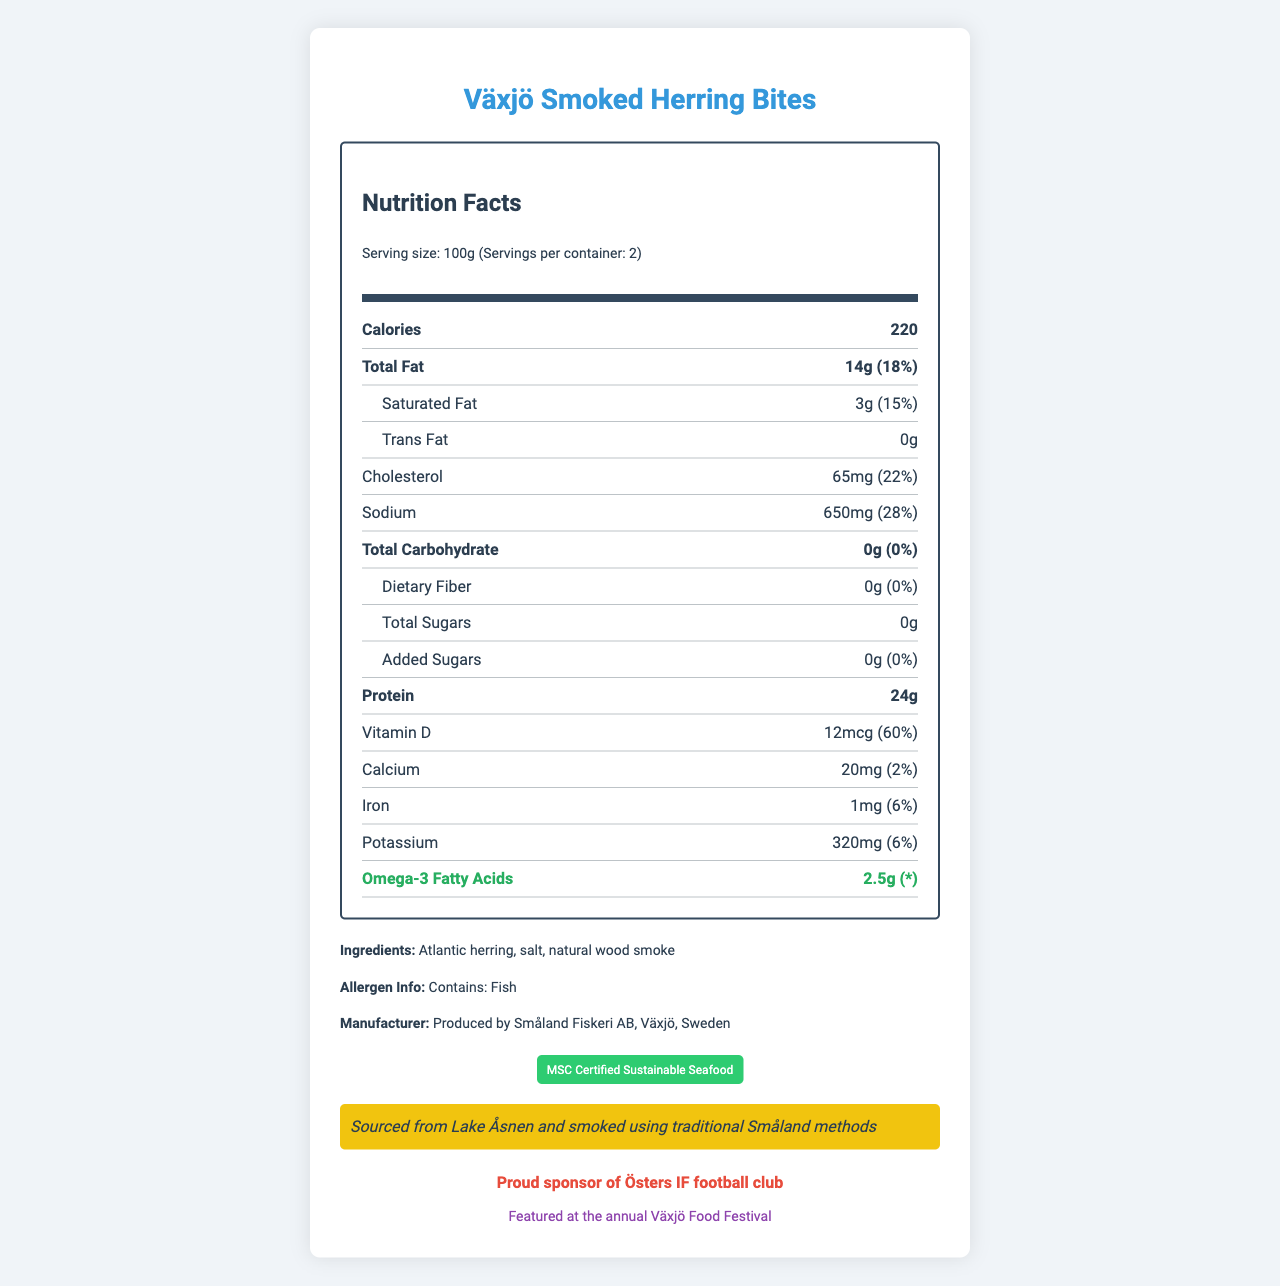how many servings are in the container? The document indicates that there are 2 servings per container.
Answer: 2 how many calories are in one serving? The label shows that each serving has 220 calories.
Answer: 220 what is the amount of omega-3 fatty acids in one serving? The document lists 2.5g of omega-3 fatty acids per serving.
Answer: 2.5g what company manufactures Växjö Smoked Herring Bites? The manufacturer is stated to be Småland Fiskeri AB, Växjö, Sweden.
Answer: Småland Fiskeri AB are these herring bites a good source of vitamin D? The document shows that one serving provides 60% of the daily value of vitamin D.
Answer: Yes how much sodium does one serving of Växjö Smoked Herring Bites contain? The label indicates that one serving contains 650mg of sodium.
Answer: 650mg which of the following is an ingredient in Växjö Smoked Herring Bites? I. Atlantic herring II. Tuna III. Salmon The ingredients list specifies Atlantic herring, salt, and natural wood smoke.
Answer: I. Atlantic herring what is the daily value percentage of total fat in one serving? A. 18% B. 15% C. 22% The total fat content for one serving is 14g, which corresponds to 18% of the daily value.
Answer: A. 18% which community event features Växjö Smoked Herring Bites? 1. Växjö Food Festival 2. Växjö Music Festival 3. Växjö Art Festival The document states that the Växjö Smoked Herring Bites are featured at the annual Växjö Food Festival.
Answer: 1. Växjö Food Festival is there any added sugar in Växjö Smoked Herring Bites? The label states there are 0g of added sugars.
Answer: No summarize the main nutritional aspects of Växjö Smoked Herring Bites. The nutritional facts highlight that these herring bites are a protein-rich, low-carb snack with significant omega-3 and vitamin D content, useful for a balanced diet.
Answer: Växjö Smoked Herring Bites contain 220 calories per serving with 14g of total fat, including 3g of saturated fat, 0g of trans fat, 65mg of cholesterol, 650mg of sodium, 0g of carbohydrates, and 24g of protein. They are a good source of omega-3 fatty acids (2.5g) and vitamin D (60% DV). The ingredients are minimal and include Atlantic herring, salt, and natural wood smoke. what is the exact amount of calories from fat in a serving? The label provides the total fat amount (14g) but does not specify the calories derived from fat.
Answer: Cannot be determined 